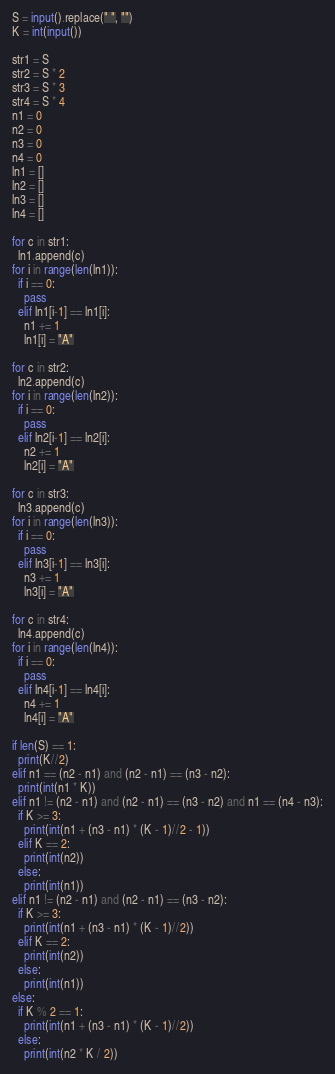<code> <loc_0><loc_0><loc_500><loc_500><_Python_>S = input().replace(" ", "")
K = int(input())

str1 = S
str2 = S * 2
str3 = S * 3
str4 = S * 4
n1 = 0
n2 = 0
n3 = 0
n4 = 0
ln1 = []
ln2 = []
ln3 = []
ln4 = []

for c in str1:
  ln1.append(c)
for i in range(len(ln1)):
  if i == 0:
    pass
  elif ln1[i-1] == ln1[i]:
    n1 += 1
    ln1[i] = "A"
    
for c in str2:
  ln2.append(c)
for i in range(len(ln2)):
  if i == 0:
    pass
  elif ln2[i-1] == ln2[i]:
    n2 += 1
    ln2[i] = "A"
    
for c in str3:
  ln3.append(c)
for i in range(len(ln3)):
  if i == 0:
    pass
  elif ln3[i-1] == ln3[i]:
    n3 += 1
    ln3[i] = "A"
    
for c in str4:
  ln4.append(c)
for i in range(len(ln4)):
  if i == 0:
    pass
  elif ln4[i-1] == ln4[i]:
    n4 += 1
    ln4[i] = "A"
  
if len(S) == 1:
  print(K//2)
elif n1 == (n2 - n1) and (n2 - n1) == (n3 - n2):
  print(int(n1 * K))
elif n1 != (n2 - n1) and (n2 - n1) == (n3 - n2) and n1 == (n4 - n3):
  if K >= 3:
    print(int(n1 + (n3 - n1) * (K - 1)//2 - 1))
  elif K == 2:
    print(int(n2))
  else:
    print(int(n1))
elif n1 != (n2 - n1) and (n2 - n1) == (n3 - n2):
  if K >= 3:
    print(int(n1 + (n3 - n1) * (K - 1)//2))
  elif K == 2:
    print(int(n2))
  else:
    print(int(n1))
else:
  if K % 2 == 1:
    print(int(n1 + (n3 - n1) * (K - 1)//2))
  else:
    print(int(n2 * K / 2))
</code> 